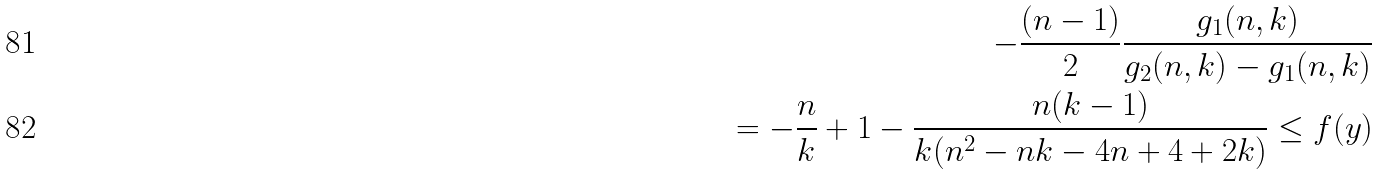<formula> <loc_0><loc_0><loc_500><loc_500>- \frac { ( n - 1 ) } { 2 } \frac { g _ { 1 } ( n , k ) } { g _ { 2 } ( n , k ) - g _ { 1 } ( n , k ) } \\ = - \frac { n } { k } + 1 - \frac { n ( k - 1 ) } { k ( n ^ { 2 } - n k - 4 n + 4 + 2 k ) } \leq f ( y )</formula> 